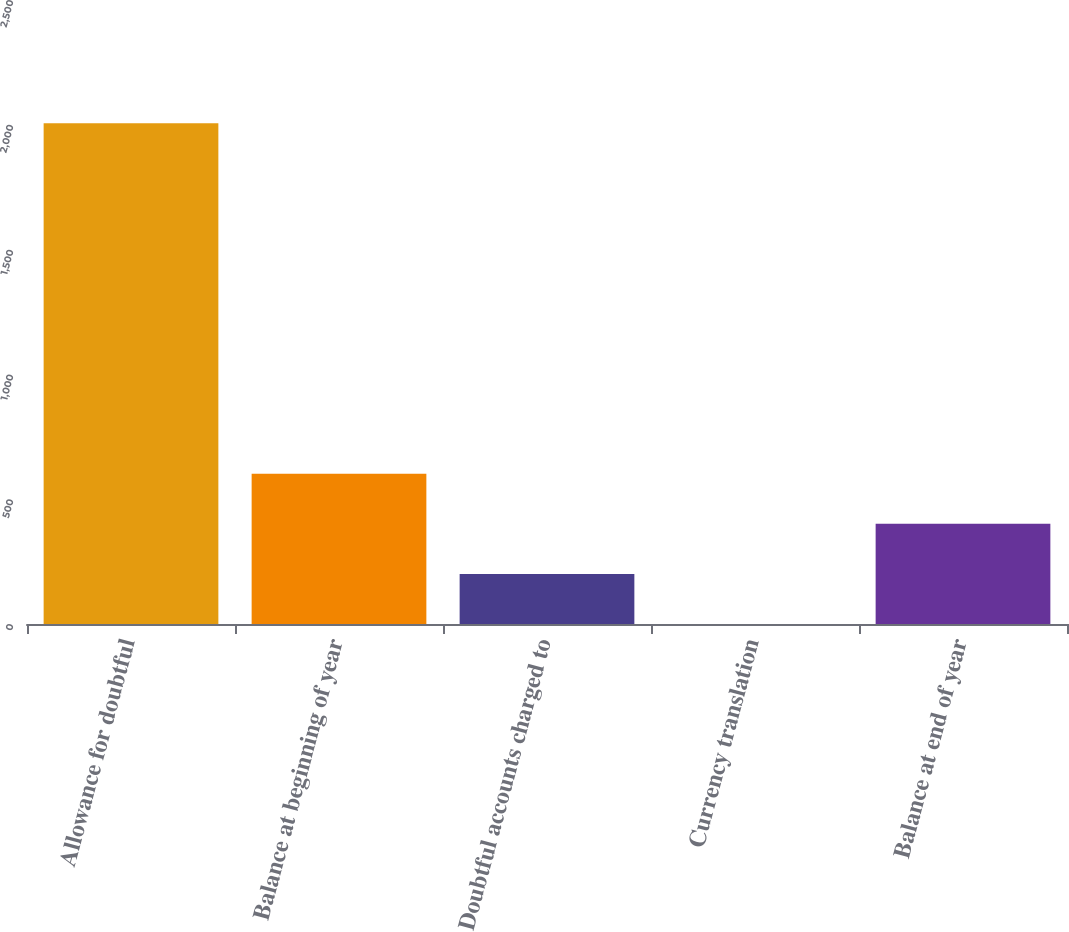<chart> <loc_0><loc_0><loc_500><loc_500><bar_chart><fcel>Allowance for doubtful<fcel>Balance at beginning of year<fcel>Doubtful accounts charged to<fcel>Currency translation<fcel>Balance at end of year<nl><fcel>2006<fcel>601.94<fcel>200.78<fcel>0.2<fcel>401.36<nl></chart> 